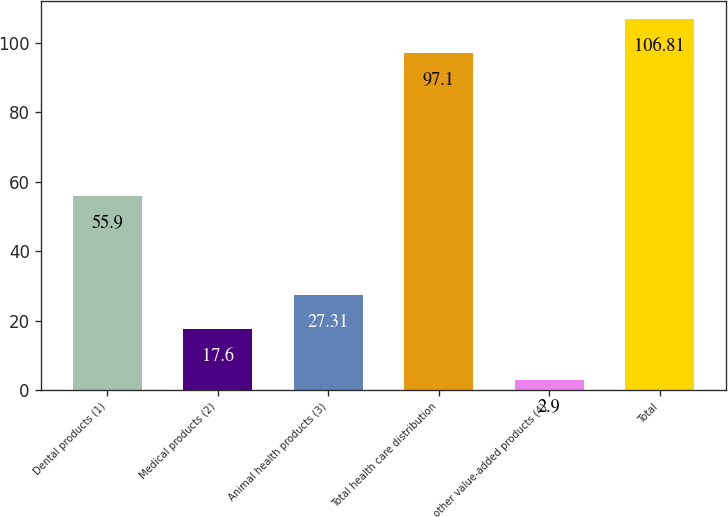Convert chart. <chart><loc_0><loc_0><loc_500><loc_500><bar_chart><fcel>Dental products (1)<fcel>Medical products (2)<fcel>Animal health products (3)<fcel>Total health care distribution<fcel>other value-added products (4)<fcel>Total<nl><fcel>55.9<fcel>17.6<fcel>27.31<fcel>97.1<fcel>2.9<fcel>106.81<nl></chart> 